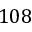<formula> <loc_0><loc_0><loc_500><loc_500>1 0 8</formula> 